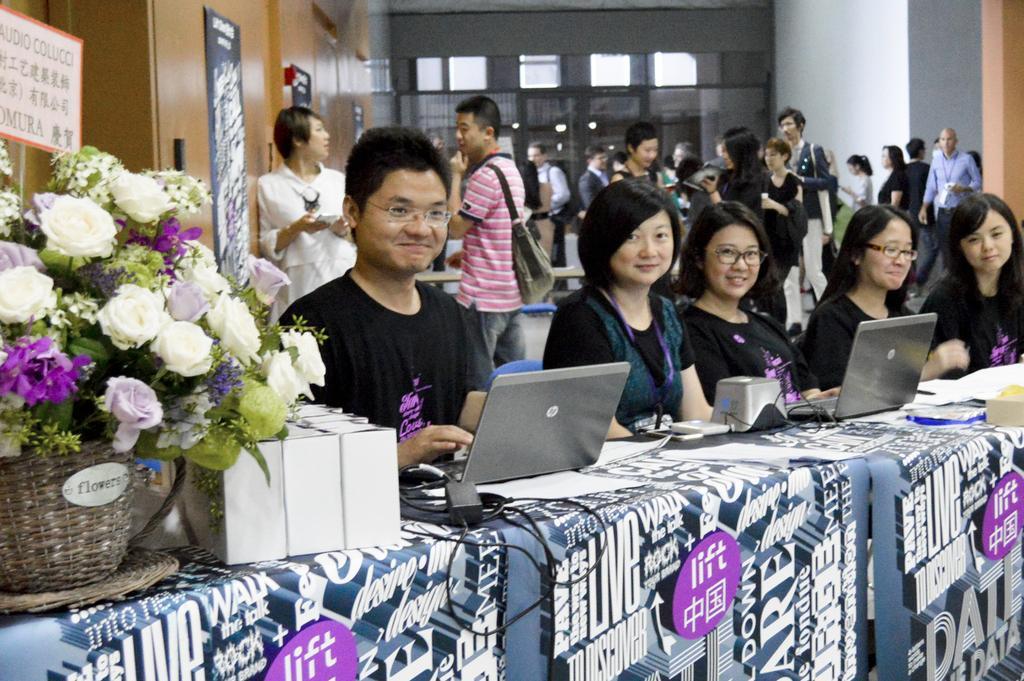Please provide a concise description of this image. In this picture I can observe some people sitting in front of a table on which laptops are placed. I can observe women and a man. On the left side I can observe a bouquet placed on the table. In the background there are some people standing on the floor. 